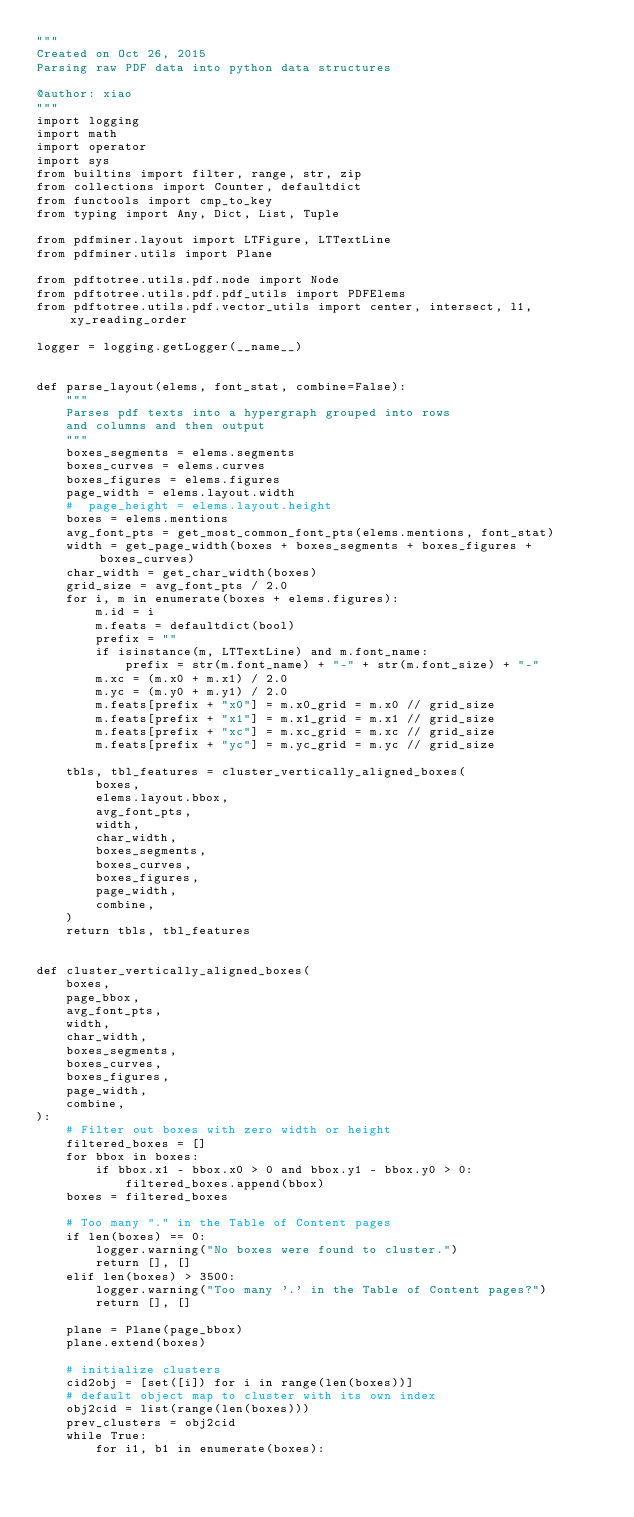Convert code to text. <code><loc_0><loc_0><loc_500><loc_500><_Python_>"""
Created on Oct 26, 2015
Parsing raw PDF data into python data structures

@author: xiao
"""
import logging
import math
import operator
import sys
from builtins import filter, range, str, zip
from collections import Counter, defaultdict
from functools import cmp_to_key
from typing import Any, Dict, List, Tuple

from pdfminer.layout import LTFigure, LTTextLine
from pdfminer.utils import Plane

from pdftotree.utils.pdf.node import Node
from pdftotree.utils.pdf.pdf_utils import PDFElems
from pdftotree.utils.pdf.vector_utils import center, intersect, l1, xy_reading_order

logger = logging.getLogger(__name__)


def parse_layout(elems, font_stat, combine=False):
    """
    Parses pdf texts into a hypergraph grouped into rows
    and columns and then output
    """
    boxes_segments = elems.segments
    boxes_curves = elems.curves
    boxes_figures = elems.figures
    page_width = elems.layout.width
    #  page_height = elems.layout.height
    boxes = elems.mentions
    avg_font_pts = get_most_common_font_pts(elems.mentions, font_stat)
    width = get_page_width(boxes + boxes_segments + boxes_figures + boxes_curves)
    char_width = get_char_width(boxes)
    grid_size = avg_font_pts / 2.0
    for i, m in enumerate(boxes + elems.figures):
        m.id = i
        m.feats = defaultdict(bool)
        prefix = ""
        if isinstance(m, LTTextLine) and m.font_name:
            prefix = str(m.font_name) + "-" + str(m.font_size) + "-"
        m.xc = (m.x0 + m.x1) / 2.0
        m.yc = (m.y0 + m.y1) / 2.0
        m.feats[prefix + "x0"] = m.x0_grid = m.x0 // grid_size
        m.feats[prefix + "x1"] = m.x1_grid = m.x1 // grid_size
        m.feats[prefix + "xc"] = m.xc_grid = m.xc // grid_size
        m.feats[prefix + "yc"] = m.yc_grid = m.yc // grid_size

    tbls, tbl_features = cluster_vertically_aligned_boxes(
        boxes,
        elems.layout.bbox,
        avg_font_pts,
        width,
        char_width,
        boxes_segments,
        boxes_curves,
        boxes_figures,
        page_width,
        combine,
    )
    return tbls, tbl_features


def cluster_vertically_aligned_boxes(
    boxes,
    page_bbox,
    avg_font_pts,
    width,
    char_width,
    boxes_segments,
    boxes_curves,
    boxes_figures,
    page_width,
    combine,
):
    # Filter out boxes with zero width or height
    filtered_boxes = []
    for bbox in boxes:
        if bbox.x1 - bbox.x0 > 0 and bbox.y1 - bbox.y0 > 0:
            filtered_boxes.append(bbox)
    boxes = filtered_boxes

    # Too many "." in the Table of Content pages
    if len(boxes) == 0:
        logger.warning("No boxes were found to cluster.")
        return [], []
    elif len(boxes) > 3500:
        logger.warning("Too many '.' in the Table of Content pages?")
        return [], []

    plane = Plane(page_bbox)
    plane.extend(boxes)

    # initialize clusters
    cid2obj = [set([i]) for i in range(len(boxes))]
    # default object map to cluster with its own index
    obj2cid = list(range(len(boxes)))
    prev_clusters = obj2cid
    while True:
        for i1, b1 in enumerate(boxes):</code> 